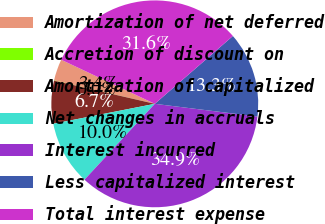Convert chart to OTSL. <chart><loc_0><loc_0><loc_500><loc_500><pie_chart><fcel>Amortization of net deferred<fcel>Accretion of discount on<fcel>Amortization of capitalized<fcel>Net changes in accruals<fcel>Interest incurred<fcel>Less capitalized interest<fcel>Total interest expense<nl><fcel>3.36%<fcel>0.04%<fcel>6.69%<fcel>10.02%<fcel>34.94%<fcel>13.34%<fcel>31.61%<nl></chart> 